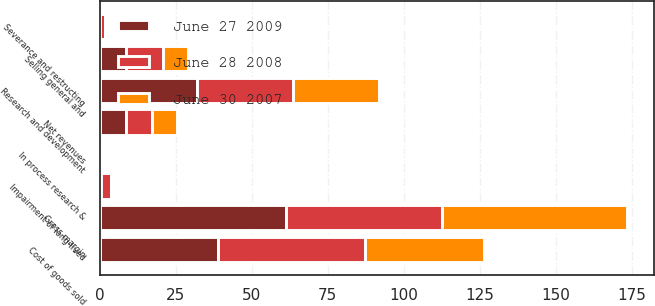<chart> <loc_0><loc_0><loc_500><loc_500><stacked_bar_chart><ecel><fcel>Net revenues<fcel>Cost of goods sold<fcel>Gross margin<fcel>Research and development<fcel>Selling general and<fcel>In process research &<fcel>Impairment of long-lived<fcel>Severance and restructing<nl><fcel>June 28 2008<fcel>8.5<fcel>48.4<fcel>51.6<fcel>31.7<fcel>12.4<fcel>0.2<fcel>3.1<fcel>1.7<nl><fcel>June 30 2007<fcel>8.5<fcel>39.2<fcel>60.8<fcel>28.3<fcel>8.1<fcel>0<fcel>0<fcel>0.7<nl><fcel>June 27 2009<fcel>8.5<fcel>38.9<fcel>61.1<fcel>31.9<fcel>8.5<fcel>0<fcel>0.5<fcel>0<nl></chart> 